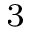Convert formula to latex. <formula><loc_0><loc_0><loc_500><loc_500>_ { 3 }</formula> 